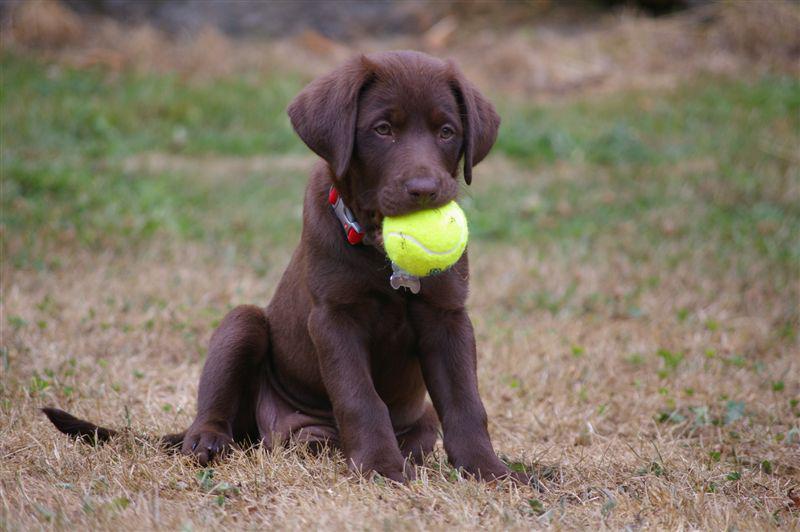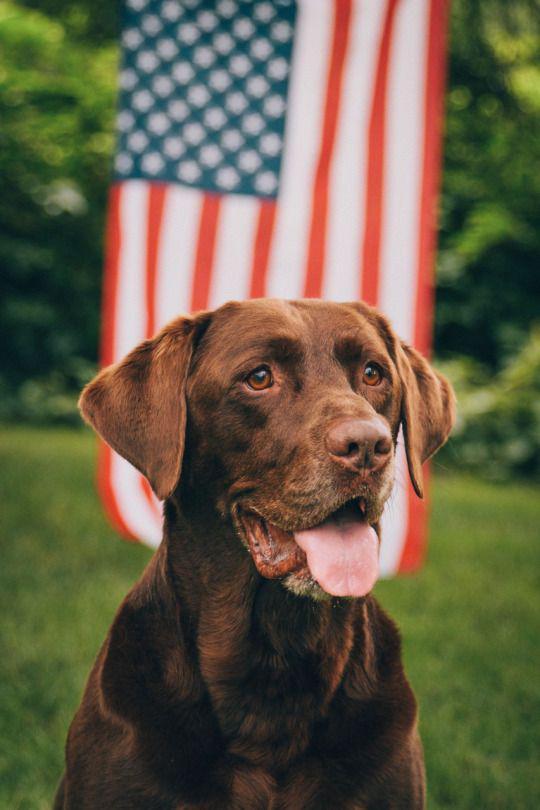The first image is the image on the left, the second image is the image on the right. Examine the images to the left and right. Is the description "No grassy ground is visible in one of the dog images." accurate? Answer yes or no. No. 